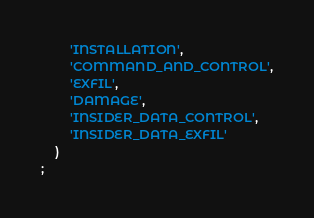<code> <loc_0><loc_0><loc_500><loc_500><_SQL_>        'INSTALLATION',
        'COMMAND_AND_CONTROL',
        'EXFIL',
        'DAMAGE',
        'INSIDER_DATA_CONTROL',
        'INSIDER_DATA_EXFIL'
    )
;
</code> 